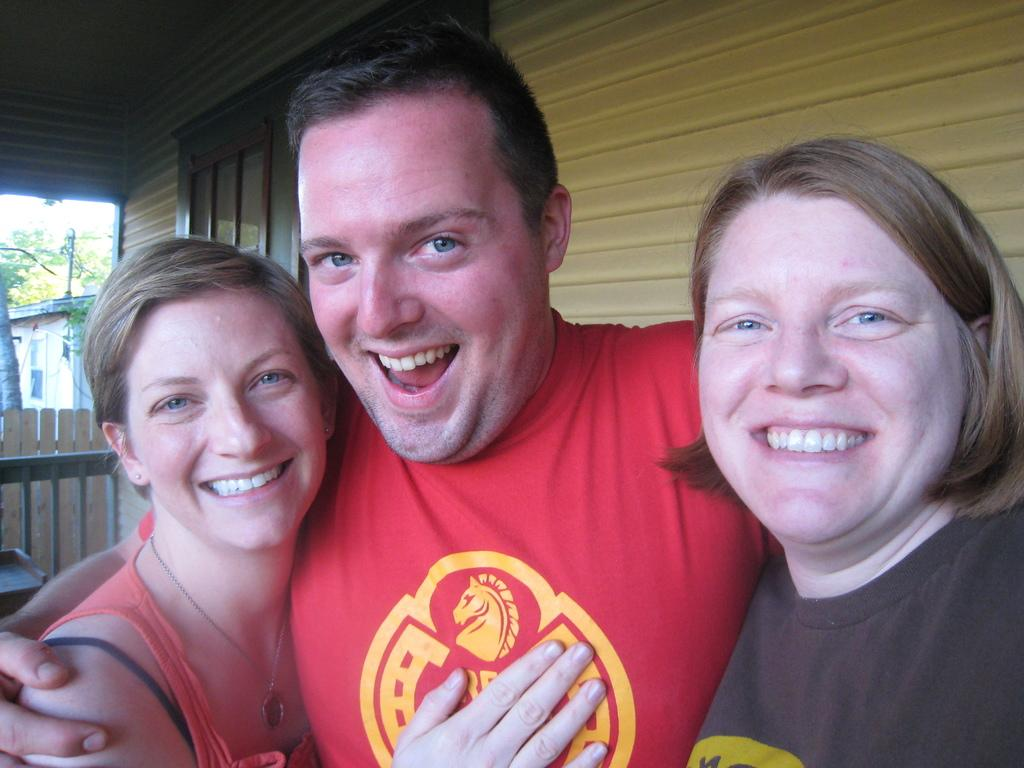How many people are present in the image? There are three people in the image. What are the people doing in the image? The people are standing in front of a building. What can be seen in the background of the image? There is a tree, a fence, a building, and a table in the background of the image. What type of property is being sold by the women in the image? There are no women present in the image, and no property is being sold. 